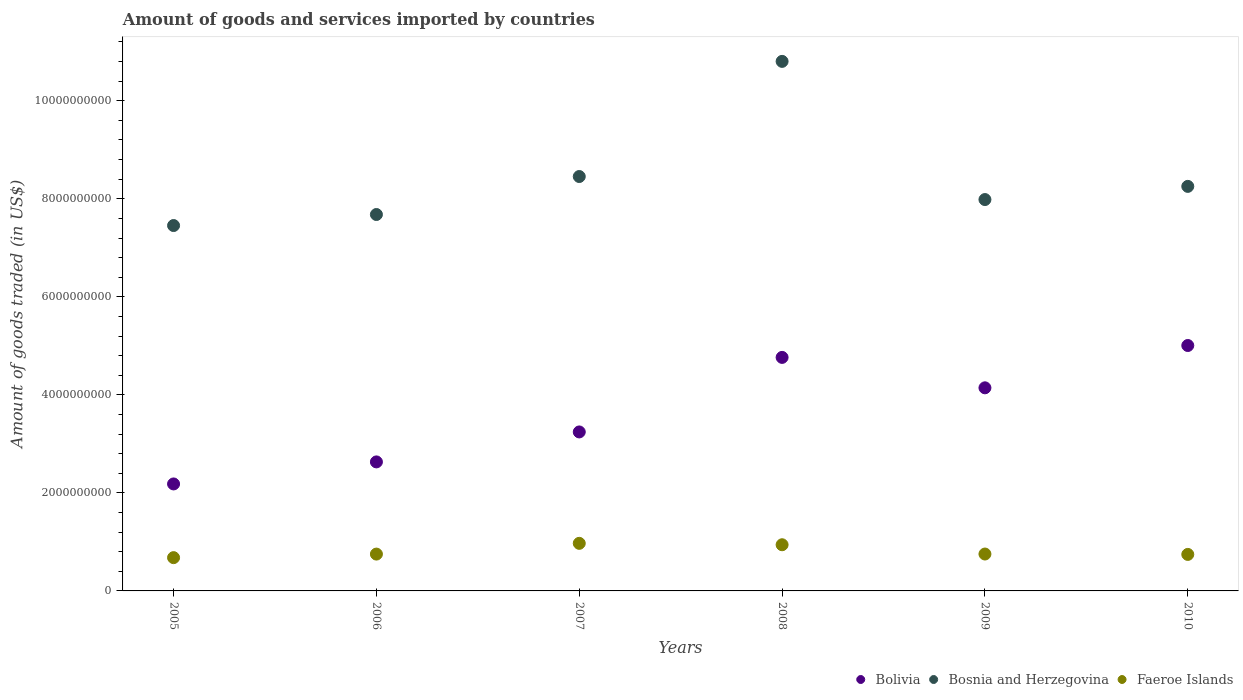What is the total amount of goods and services imported in Faeroe Islands in 2007?
Your answer should be compact. 9.71e+08. Across all years, what is the maximum total amount of goods and services imported in Faeroe Islands?
Make the answer very short. 9.71e+08. Across all years, what is the minimum total amount of goods and services imported in Bosnia and Herzegovina?
Give a very brief answer. 7.45e+09. In which year was the total amount of goods and services imported in Bosnia and Herzegovina maximum?
Provide a succinct answer. 2008. In which year was the total amount of goods and services imported in Faeroe Islands minimum?
Offer a terse response. 2005. What is the total total amount of goods and services imported in Faeroe Islands in the graph?
Your response must be concise. 4.84e+09. What is the difference between the total amount of goods and services imported in Bosnia and Herzegovina in 2006 and that in 2008?
Provide a short and direct response. -3.12e+09. What is the difference between the total amount of goods and services imported in Faeroe Islands in 2006 and the total amount of goods and services imported in Bosnia and Herzegovina in 2009?
Offer a very short reply. -7.23e+09. What is the average total amount of goods and services imported in Bolivia per year?
Offer a very short reply. 3.66e+09. In the year 2007, what is the difference between the total amount of goods and services imported in Faeroe Islands and total amount of goods and services imported in Bolivia?
Keep it short and to the point. -2.27e+09. What is the ratio of the total amount of goods and services imported in Bosnia and Herzegovina in 2008 to that in 2010?
Your answer should be compact. 1.31. Is the difference between the total amount of goods and services imported in Faeroe Islands in 2006 and 2007 greater than the difference between the total amount of goods and services imported in Bolivia in 2006 and 2007?
Make the answer very short. Yes. What is the difference between the highest and the second highest total amount of goods and services imported in Bosnia and Herzegovina?
Ensure brevity in your answer.  2.35e+09. What is the difference between the highest and the lowest total amount of goods and services imported in Bolivia?
Provide a succinct answer. 2.82e+09. In how many years, is the total amount of goods and services imported in Bosnia and Herzegovina greater than the average total amount of goods and services imported in Bosnia and Herzegovina taken over all years?
Make the answer very short. 2. Is the sum of the total amount of goods and services imported in Bolivia in 2006 and 2010 greater than the maximum total amount of goods and services imported in Bosnia and Herzegovina across all years?
Offer a very short reply. No. Does the total amount of goods and services imported in Faeroe Islands monotonically increase over the years?
Provide a succinct answer. No. Is the total amount of goods and services imported in Bolivia strictly greater than the total amount of goods and services imported in Faeroe Islands over the years?
Make the answer very short. Yes. Is the total amount of goods and services imported in Bosnia and Herzegovina strictly less than the total amount of goods and services imported in Bolivia over the years?
Your answer should be compact. No. How many dotlines are there?
Provide a short and direct response. 3. How many years are there in the graph?
Make the answer very short. 6. Are the values on the major ticks of Y-axis written in scientific E-notation?
Offer a terse response. No. Does the graph contain any zero values?
Your answer should be compact. No. Does the graph contain grids?
Offer a terse response. No. Where does the legend appear in the graph?
Your answer should be compact. Bottom right. What is the title of the graph?
Your response must be concise. Amount of goods and services imported by countries. What is the label or title of the Y-axis?
Your response must be concise. Amount of goods traded (in US$). What is the Amount of goods traded (in US$) of Bolivia in 2005?
Give a very brief answer. 2.18e+09. What is the Amount of goods traded (in US$) in Bosnia and Herzegovina in 2005?
Offer a terse response. 7.45e+09. What is the Amount of goods traded (in US$) in Faeroe Islands in 2005?
Your answer should be very brief. 6.79e+08. What is the Amount of goods traded (in US$) of Bolivia in 2006?
Provide a short and direct response. 2.63e+09. What is the Amount of goods traded (in US$) in Bosnia and Herzegovina in 2006?
Give a very brief answer. 7.68e+09. What is the Amount of goods traded (in US$) of Faeroe Islands in 2006?
Ensure brevity in your answer.  7.51e+08. What is the Amount of goods traded (in US$) in Bolivia in 2007?
Offer a terse response. 3.24e+09. What is the Amount of goods traded (in US$) of Bosnia and Herzegovina in 2007?
Your answer should be very brief. 8.45e+09. What is the Amount of goods traded (in US$) of Faeroe Islands in 2007?
Ensure brevity in your answer.  9.71e+08. What is the Amount of goods traded (in US$) in Bolivia in 2008?
Your response must be concise. 4.76e+09. What is the Amount of goods traded (in US$) of Bosnia and Herzegovina in 2008?
Provide a short and direct response. 1.08e+1. What is the Amount of goods traded (in US$) in Faeroe Islands in 2008?
Offer a terse response. 9.42e+08. What is the Amount of goods traded (in US$) in Bolivia in 2009?
Keep it short and to the point. 4.14e+09. What is the Amount of goods traded (in US$) of Bosnia and Herzegovina in 2009?
Your response must be concise. 7.98e+09. What is the Amount of goods traded (in US$) in Faeroe Islands in 2009?
Keep it short and to the point. 7.53e+08. What is the Amount of goods traded (in US$) of Bolivia in 2010?
Ensure brevity in your answer.  5.01e+09. What is the Amount of goods traded (in US$) of Bosnia and Herzegovina in 2010?
Ensure brevity in your answer.  8.25e+09. What is the Amount of goods traded (in US$) of Faeroe Islands in 2010?
Keep it short and to the point. 7.45e+08. Across all years, what is the maximum Amount of goods traded (in US$) in Bolivia?
Provide a succinct answer. 5.01e+09. Across all years, what is the maximum Amount of goods traded (in US$) in Bosnia and Herzegovina?
Give a very brief answer. 1.08e+1. Across all years, what is the maximum Amount of goods traded (in US$) of Faeroe Islands?
Offer a terse response. 9.71e+08. Across all years, what is the minimum Amount of goods traded (in US$) of Bolivia?
Ensure brevity in your answer.  2.18e+09. Across all years, what is the minimum Amount of goods traded (in US$) of Bosnia and Herzegovina?
Keep it short and to the point. 7.45e+09. Across all years, what is the minimum Amount of goods traded (in US$) of Faeroe Islands?
Your answer should be very brief. 6.79e+08. What is the total Amount of goods traded (in US$) of Bolivia in the graph?
Give a very brief answer. 2.20e+1. What is the total Amount of goods traded (in US$) in Bosnia and Herzegovina in the graph?
Your answer should be very brief. 5.06e+1. What is the total Amount of goods traded (in US$) of Faeroe Islands in the graph?
Provide a short and direct response. 4.84e+09. What is the difference between the Amount of goods traded (in US$) in Bolivia in 2005 and that in 2006?
Provide a succinct answer. -4.50e+08. What is the difference between the Amount of goods traded (in US$) in Bosnia and Herzegovina in 2005 and that in 2006?
Provide a short and direct response. -2.25e+08. What is the difference between the Amount of goods traded (in US$) in Faeroe Islands in 2005 and that in 2006?
Offer a very short reply. -7.25e+07. What is the difference between the Amount of goods traded (in US$) in Bolivia in 2005 and that in 2007?
Ensure brevity in your answer.  -1.06e+09. What is the difference between the Amount of goods traded (in US$) of Bosnia and Herzegovina in 2005 and that in 2007?
Provide a short and direct response. -1.00e+09. What is the difference between the Amount of goods traded (in US$) in Faeroe Islands in 2005 and that in 2007?
Make the answer very short. -2.92e+08. What is the difference between the Amount of goods traded (in US$) of Bolivia in 2005 and that in 2008?
Provide a short and direct response. -2.58e+09. What is the difference between the Amount of goods traded (in US$) in Bosnia and Herzegovina in 2005 and that in 2008?
Ensure brevity in your answer.  -3.35e+09. What is the difference between the Amount of goods traded (in US$) in Faeroe Islands in 2005 and that in 2008?
Your answer should be very brief. -2.63e+08. What is the difference between the Amount of goods traded (in US$) in Bolivia in 2005 and that in 2009?
Your answer should be very brief. -1.96e+09. What is the difference between the Amount of goods traded (in US$) in Bosnia and Herzegovina in 2005 and that in 2009?
Your response must be concise. -5.30e+08. What is the difference between the Amount of goods traded (in US$) of Faeroe Islands in 2005 and that in 2009?
Your answer should be very brief. -7.37e+07. What is the difference between the Amount of goods traded (in US$) of Bolivia in 2005 and that in 2010?
Your response must be concise. -2.82e+09. What is the difference between the Amount of goods traded (in US$) in Bosnia and Herzegovina in 2005 and that in 2010?
Provide a short and direct response. -7.99e+08. What is the difference between the Amount of goods traded (in US$) of Faeroe Islands in 2005 and that in 2010?
Your answer should be very brief. -6.58e+07. What is the difference between the Amount of goods traded (in US$) of Bolivia in 2006 and that in 2007?
Provide a succinct answer. -6.11e+08. What is the difference between the Amount of goods traded (in US$) of Bosnia and Herzegovina in 2006 and that in 2007?
Make the answer very short. -7.75e+08. What is the difference between the Amount of goods traded (in US$) in Faeroe Islands in 2006 and that in 2007?
Your response must be concise. -2.19e+08. What is the difference between the Amount of goods traded (in US$) of Bolivia in 2006 and that in 2008?
Your response must be concise. -2.13e+09. What is the difference between the Amount of goods traded (in US$) of Bosnia and Herzegovina in 2006 and that in 2008?
Your answer should be compact. -3.12e+09. What is the difference between the Amount of goods traded (in US$) of Faeroe Islands in 2006 and that in 2008?
Provide a succinct answer. -1.91e+08. What is the difference between the Amount of goods traded (in US$) in Bolivia in 2006 and that in 2009?
Your response must be concise. -1.51e+09. What is the difference between the Amount of goods traded (in US$) in Bosnia and Herzegovina in 2006 and that in 2009?
Provide a succinct answer. -3.05e+08. What is the difference between the Amount of goods traded (in US$) in Faeroe Islands in 2006 and that in 2009?
Provide a short and direct response. -1.19e+06. What is the difference between the Amount of goods traded (in US$) in Bolivia in 2006 and that in 2010?
Your answer should be very brief. -2.37e+09. What is the difference between the Amount of goods traded (in US$) in Bosnia and Herzegovina in 2006 and that in 2010?
Provide a short and direct response. -5.74e+08. What is the difference between the Amount of goods traded (in US$) of Faeroe Islands in 2006 and that in 2010?
Provide a short and direct response. 6.74e+06. What is the difference between the Amount of goods traded (in US$) of Bolivia in 2007 and that in 2008?
Provide a succinct answer. -1.52e+09. What is the difference between the Amount of goods traded (in US$) of Bosnia and Herzegovina in 2007 and that in 2008?
Offer a very short reply. -2.35e+09. What is the difference between the Amount of goods traded (in US$) of Faeroe Islands in 2007 and that in 2008?
Give a very brief answer. 2.87e+07. What is the difference between the Amount of goods traded (in US$) of Bolivia in 2007 and that in 2009?
Ensure brevity in your answer.  -9.00e+08. What is the difference between the Amount of goods traded (in US$) of Bosnia and Herzegovina in 2007 and that in 2009?
Your answer should be very brief. 4.70e+08. What is the difference between the Amount of goods traded (in US$) of Faeroe Islands in 2007 and that in 2009?
Offer a very short reply. 2.18e+08. What is the difference between the Amount of goods traded (in US$) of Bolivia in 2007 and that in 2010?
Offer a terse response. -1.76e+09. What is the difference between the Amount of goods traded (in US$) of Bosnia and Herzegovina in 2007 and that in 2010?
Your answer should be very brief. 2.01e+08. What is the difference between the Amount of goods traded (in US$) in Faeroe Islands in 2007 and that in 2010?
Offer a terse response. 2.26e+08. What is the difference between the Amount of goods traded (in US$) of Bolivia in 2008 and that in 2009?
Ensure brevity in your answer.  6.21e+08. What is the difference between the Amount of goods traded (in US$) in Bosnia and Herzegovina in 2008 and that in 2009?
Give a very brief answer. 2.82e+09. What is the difference between the Amount of goods traded (in US$) of Faeroe Islands in 2008 and that in 2009?
Ensure brevity in your answer.  1.89e+08. What is the difference between the Amount of goods traded (in US$) in Bolivia in 2008 and that in 2010?
Your response must be concise. -2.43e+08. What is the difference between the Amount of goods traded (in US$) in Bosnia and Herzegovina in 2008 and that in 2010?
Offer a terse response. 2.55e+09. What is the difference between the Amount of goods traded (in US$) of Faeroe Islands in 2008 and that in 2010?
Your response must be concise. 1.97e+08. What is the difference between the Amount of goods traded (in US$) in Bolivia in 2009 and that in 2010?
Provide a short and direct response. -8.63e+08. What is the difference between the Amount of goods traded (in US$) in Bosnia and Herzegovina in 2009 and that in 2010?
Your answer should be compact. -2.69e+08. What is the difference between the Amount of goods traded (in US$) of Faeroe Islands in 2009 and that in 2010?
Your answer should be very brief. 7.93e+06. What is the difference between the Amount of goods traded (in US$) in Bolivia in 2005 and the Amount of goods traded (in US$) in Bosnia and Herzegovina in 2006?
Ensure brevity in your answer.  -5.50e+09. What is the difference between the Amount of goods traded (in US$) of Bolivia in 2005 and the Amount of goods traded (in US$) of Faeroe Islands in 2006?
Provide a succinct answer. 1.43e+09. What is the difference between the Amount of goods traded (in US$) in Bosnia and Herzegovina in 2005 and the Amount of goods traded (in US$) in Faeroe Islands in 2006?
Keep it short and to the point. 6.70e+09. What is the difference between the Amount of goods traded (in US$) of Bolivia in 2005 and the Amount of goods traded (in US$) of Bosnia and Herzegovina in 2007?
Give a very brief answer. -6.27e+09. What is the difference between the Amount of goods traded (in US$) of Bolivia in 2005 and the Amount of goods traded (in US$) of Faeroe Islands in 2007?
Your answer should be very brief. 1.21e+09. What is the difference between the Amount of goods traded (in US$) of Bosnia and Herzegovina in 2005 and the Amount of goods traded (in US$) of Faeroe Islands in 2007?
Your answer should be very brief. 6.48e+09. What is the difference between the Amount of goods traded (in US$) in Bolivia in 2005 and the Amount of goods traded (in US$) in Bosnia and Herzegovina in 2008?
Your answer should be very brief. -8.62e+09. What is the difference between the Amount of goods traded (in US$) of Bolivia in 2005 and the Amount of goods traded (in US$) of Faeroe Islands in 2008?
Give a very brief answer. 1.24e+09. What is the difference between the Amount of goods traded (in US$) of Bosnia and Herzegovina in 2005 and the Amount of goods traded (in US$) of Faeroe Islands in 2008?
Make the answer very short. 6.51e+09. What is the difference between the Amount of goods traded (in US$) in Bolivia in 2005 and the Amount of goods traded (in US$) in Bosnia and Herzegovina in 2009?
Your response must be concise. -5.80e+09. What is the difference between the Amount of goods traded (in US$) of Bolivia in 2005 and the Amount of goods traded (in US$) of Faeroe Islands in 2009?
Ensure brevity in your answer.  1.43e+09. What is the difference between the Amount of goods traded (in US$) in Bosnia and Herzegovina in 2005 and the Amount of goods traded (in US$) in Faeroe Islands in 2009?
Give a very brief answer. 6.70e+09. What is the difference between the Amount of goods traded (in US$) of Bolivia in 2005 and the Amount of goods traded (in US$) of Bosnia and Herzegovina in 2010?
Your response must be concise. -6.07e+09. What is the difference between the Amount of goods traded (in US$) in Bolivia in 2005 and the Amount of goods traded (in US$) in Faeroe Islands in 2010?
Give a very brief answer. 1.44e+09. What is the difference between the Amount of goods traded (in US$) in Bosnia and Herzegovina in 2005 and the Amount of goods traded (in US$) in Faeroe Islands in 2010?
Offer a terse response. 6.71e+09. What is the difference between the Amount of goods traded (in US$) in Bolivia in 2006 and the Amount of goods traded (in US$) in Bosnia and Herzegovina in 2007?
Provide a succinct answer. -5.82e+09. What is the difference between the Amount of goods traded (in US$) of Bolivia in 2006 and the Amount of goods traded (in US$) of Faeroe Islands in 2007?
Keep it short and to the point. 1.66e+09. What is the difference between the Amount of goods traded (in US$) of Bosnia and Herzegovina in 2006 and the Amount of goods traded (in US$) of Faeroe Islands in 2007?
Keep it short and to the point. 6.71e+09. What is the difference between the Amount of goods traded (in US$) in Bolivia in 2006 and the Amount of goods traded (in US$) in Bosnia and Herzegovina in 2008?
Offer a terse response. -8.17e+09. What is the difference between the Amount of goods traded (in US$) of Bolivia in 2006 and the Amount of goods traded (in US$) of Faeroe Islands in 2008?
Offer a very short reply. 1.69e+09. What is the difference between the Amount of goods traded (in US$) of Bosnia and Herzegovina in 2006 and the Amount of goods traded (in US$) of Faeroe Islands in 2008?
Keep it short and to the point. 6.74e+09. What is the difference between the Amount of goods traded (in US$) in Bolivia in 2006 and the Amount of goods traded (in US$) in Bosnia and Herzegovina in 2009?
Keep it short and to the point. -5.35e+09. What is the difference between the Amount of goods traded (in US$) in Bolivia in 2006 and the Amount of goods traded (in US$) in Faeroe Islands in 2009?
Provide a short and direct response. 1.88e+09. What is the difference between the Amount of goods traded (in US$) of Bosnia and Herzegovina in 2006 and the Amount of goods traded (in US$) of Faeroe Islands in 2009?
Offer a terse response. 6.93e+09. What is the difference between the Amount of goods traded (in US$) of Bolivia in 2006 and the Amount of goods traded (in US$) of Bosnia and Herzegovina in 2010?
Make the answer very short. -5.62e+09. What is the difference between the Amount of goods traded (in US$) in Bolivia in 2006 and the Amount of goods traded (in US$) in Faeroe Islands in 2010?
Your answer should be very brief. 1.89e+09. What is the difference between the Amount of goods traded (in US$) of Bosnia and Herzegovina in 2006 and the Amount of goods traded (in US$) of Faeroe Islands in 2010?
Offer a very short reply. 6.93e+09. What is the difference between the Amount of goods traded (in US$) of Bolivia in 2007 and the Amount of goods traded (in US$) of Bosnia and Herzegovina in 2008?
Ensure brevity in your answer.  -7.56e+09. What is the difference between the Amount of goods traded (in US$) in Bolivia in 2007 and the Amount of goods traded (in US$) in Faeroe Islands in 2008?
Make the answer very short. 2.30e+09. What is the difference between the Amount of goods traded (in US$) of Bosnia and Herzegovina in 2007 and the Amount of goods traded (in US$) of Faeroe Islands in 2008?
Offer a very short reply. 7.51e+09. What is the difference between the Amount of goods traded (in US$) in Bolivia in 2007 and the Amount of goods traded (in US$) in Bosnia and Herzegovina in 2009?
Make the answer very short. -4.74e+09. What is the difference between the Amount of goods traded (in US$) in Bolivia in 2007 and the Amount of goods traded (in US$) in Faeroe Islands in 2009?
Provide a short and direct response. 2.49e+09. What is the difference between the Amount of goods traded (in US$) of Bosnia and Herzegovina in 2007 and the Amount of goods traded (in US$) of Faeroe Islands in 2009?
Provide a short and direct response. 7.70e+09. What is the difference between the Amount of goods traded (in US$) in Bolivia in 2007 and the Amount of goods traded (in US$) in Bosnia and Herzegovina in 2010?
Offer a very short reply. -5.01e+09. What is the difference between the Amount of goods traded (in US$) in Bolivia in 2007 and the Amount of goods traded (in US$) in Faeroe Islands in 2010?
Offer a very short reply. 2.50e+09. What is the difference between the Amount of goods traded (in US$) of Bosnia and Herzegovina in 2007 and the Amount of goods traded (in US$) of Faeroe Islands in 2010?
Your answer should be very brief. 7.71e+09. What is the difference between the Amount of goods traded (in US$) in Bolivia in 2008 and the Amount of goods traded (in US$) in Bosnia and Herzegovina in 2009?
Provide a succinct answer. -3.22e+09. What is the difference between the Amount of goods traded (in US$) in Bolivia in 2008 and the Amount of goods traded (in US$) in Faeroe Islands in 2009?
Your response must be concise. 4.01e+09. What is the difference between the Amount of goods traded (in US$) in Bosnia and Herzegovina in 2008 and the Amount of goods traded (in US$) in Faeroe Islands in 2009?
Your answer should be very brief. 1.01e+1. What is the difference between the Amount of goods traded (in US$) of Bolivia in 2008 and the Amount of goods traded (in US$) of Bosnia and Herzegovina in 2010?
Give a very brief answer. -3.49e+09. What is the difference between the Amount of goods traded (in US$) in Bolivia in 2008 and the Amount of goods traded (in US$) in Faeroe Islands in 2010?
Keep it short and to the point. 4.02e+09. What is the difference between the Amount of goods traded (in US$) of Bosnia and Herzegovina in 2008 and the Amount of goods traded (in US$) of Faeroe Islands in 2010?
Your response must be concise. 1.01e+1. What is the difference between the Amount of goods traded (in US$) in Bolivia in 2009 and the Amount of goods traded (in US$) in Bosnia and Herzegovina in 2010?
Give a very brief answer. -4.11e+09. What is the difference between the Amount of goods traded (in US$) in Bolivia in 2009 and the Amount of goods traded (in US$) in Faeroe Islands in 2010?
Keep it short and to the point. 3.40e+09. What is the difference between the Amount of goods traded (in US$) in Bosnia and Herzegovina in 2009 and the Amount of goods traded (in US$) in Faeroe Islands in 2010?
Your response must be concise. 7.24e+09. What is the average Amount of goods traded (in US$) of Bolivia per year?
Give a very brief answer. 3.66e+09. What is the average Amount of goods traded (in US$) in Bosnia and Herzegovina per year?
Your response must be concise. 8.44e+09. What is the average Amount of goods traded (in US$) of Faeroe Islands per year?
Provide a succinct answer. 8.07e+08. In the year 2005, what is the difference between the Amount of goods traded (in US$) in Bolivia and Amount of goods traded (in US$) in Bosnia and Herzegovina?
Your answer should be very brief. -5.27e+09. In the year 2005, what is the difference between the Amount of goods traded (in US$) of Bolivia and Amount of goods traded (in US$) of Faeroe Islands?
Make the answer very short. 1.50e+09. In the year 2005, what is the difference between the Amount of goods traded (in US$) in Bosnia and Herzegovina and Amount of goods traded (in US$) in Faeroe Islands?
Provide a succinct answer. 6.78e+09. In the year 2006, what is the difference between the Amount of goods traded (in US$) in Bolivia and Amount of goods traded (in US$) in Bosnia and Herzegovina?
Keep it short and to the point. -5.05e+09. In the year 2006, what is the difference between the Amount of goods traded (in US$) in Bolivia and Amount of goods traded (in US$) in Faeroe Islands?
Give a very brief answer. 1.88e+09. In the year 2006, what is the difference between the Amount of goods traded (in US$) in Bosnia and Herzegovina and Amount of goods traded (in US$) in Faeroe Islands?
Give a very brief answer. 6.93e+09. In the year 2007, what is the difference between the Amount of goods traded (in US$) in Bolivia and Amount of goods traded (in US$) in Bosnia and Herzegovina?
Offer a terse response. -5.21e+09. In the year 2007, what is the difference between the Amount of goods traded (in US$) of Bolivia and Amount of goods traded (in US$) of Faeroe Islands?
Give a very brief answer. 2.27e+09. In the year 2007, what is the difference between the Amount of goods traded (in US$) in Bosnia and Herzegovina and Amount of goods traded (in US$) in Faeroe Islands?
Your response must be concise. 7.48e+09. In the year 2008, what is the difference between the Amount of goods traded (in US$) in Bolivia and Amount of goods traded (in US$) in Bosnia and Herzegovina?
Your answer should be compact. -6.04e+09. In the year 2008, what is the difference between the Amount of goods traded (in US$) of Bolivia and Amount of goods traded (in US$) of Faeroe Islands?
Give a very brief answer. 3.82e+09. In the year 2008, what is the difference between the Amount of goods traded (in US$) of Bosnia and Herzegovina and Amount of goods traded (in US$) of Faeroe Islands?
Offer a terse response. 9.86e+09. In the year 2009, what is the difference between the Amount of goods traded (in US$) in Bolivia and Amount of goods traded (in US$) in Bosnia and Herzegovina?
Provide a succinct answer. -3.84e+09. In the year 2009, what is the difference between the Amount of goods traded (in US$) in Bolivia and Amount of goods traded (in US$) in Faeroe Islands?
Your answer should be very brief. 3.39e+09. In the year 2009, what is the difference between the Amount of goods traded (in US$) in Bosnia and Herzegovina and Amount of goods traded (in US$) in Faeroe Islands?
Ensure brevity in your answer.  7.23e+09. In the year 2010, what is the difference between the Amount of goods traded (in US$) of Bolivia and Amount of goods traded (in US$) of Bosnia and Herzegovina?
Offer a very short reply. -3.25e+09. In the year 2010, what is the difference between the Amount of goods traded (in US$) in Bolivia and Amount of goods traded (in US$) in Faeroe Islands?
Your answer should be very brief. 4.26e+09. In the year 2010, what is the difference between the Amount of goods traded (in US$) in Bosnia and Herzegovina and Amount of goods traded (in US$) in Faeroe Islands?
Provide a short and direct response. 7.51e+09. What is the ratio of the Amount of goods traded (in US$) of Bolivia in 2005 to that in 2006?
Provide a short and direct response. 0.83. What is the ratio of the Amount of goods traded (in US$) in Bosnia and Herzegovina in 2005 to that in 2006?
Keep it short and to the point. 0.97. What is the ratio of the Amount of goods traded (in US$) of Faeroe Islands in 2005 to that in 2006?
Your answer should be compact. 0.9. What is the ratio of the Amount of goods traded (in US$) of Bolivia in 2005 to that in 2007?
Your response must be concise. 0.67. What is the ratio of the Amount of goods traded (in US$) of Bosnia and Herzegovina in 2005 to that in 2007?
Offer a very short reply. 0.88. What is the ratio of the Amount of goods traded (in US$) in Faeroe Islands in 2005 to that in 2007?
Give a very brief answer. 0.7. What is the ratio of the Amount of goods traded (in US$) in Bolivia in 2005 to that in 2008?
Provide a succinct answer. 0.46. What is the ratio of the Amount of goods traded (in US$) in Bosnia and Herzegovina in 2005 to that in 2008?
Your answer should be compact. 0.69. What is the ratio of the Amount of goods traded (in US$) in Faeroe Islands in 2005 to that in 2008?
Give a very brief answer. 0.72. What is the ratio of the Amount of goods traded (in US$) of Bolivia in 2005 to that in 2009?
Your answer should be very brief. 0.53. What is the ratio of the Amount of goods traded (in US$) of Bosnia and Herzegovina in 2005 to that in 2009?
Make the answer very short. 0.93. What is the ratio of the Amount of goods traded (in US$) in Faeroe Islands in 2005 to that in 2009?
Offer a terse response. 0.9. What is the ratio of the Amount of goods traded (in US$) in Bolivia in 2005 to that in 2010?
Your response must be concise. 0.44. What is the ratio of the Amount of goods traded (in US$) in Bosnia and Herzegovina in 2005 to that in 2010?
Ensure brevity in your answer.  0.9. What is the ratio of the Amount of goods traded (in US$) in Faeroe Islands in 2005 to that in 2010?
Give a very brief answer. 0.91. What is the ratio of the Amount of goods traded (in US$) of Bolivia in 2006 to that in 2007?
Your answer should be compact. 0.81. What is the ratio of the Amount of goods traded (in US$) of Bosnia and Herzegovina in 2006 to that in 2007?
Give a very brief answer. 0.91. What is the ratio of the Amount of goods traded (in US$) of Faeroe Islands in 2006 to that in 2007?
Your answer should be very brief. 0.77. What is the ratio of the Amount of goods traded (in US$) of Bolivia in 2006 to that in 2008?
Your answer should be very brief. 0.55. What is the ratio of the Amount of goods traded (in US$) in Bosnia and Herzegovina in 2006 to that in 2008?
Your answer should be very brief. 0.71. What is the ratio of the Amount of goods traded (in US$) in Faeroe Islands in 2006 to that in 2008?
Give a very brief answer. 0.8. What is the ratio of the Amount of goods traded (in US$) of Bolivia in 2006 to that in 2009?
Ensure brevity in your answer.  0.64. What is the ratio of the Amount of goods traded (in US$) in Bosnia and Herzegovina in 2006 to that in 2009?
Keep it short and to the point. 0.96. What is the ratio of the Amount of goods traded (in US$) of Bolivia in 2006 to that in 2010?
Keep it short and to the point. 0.53. What is the ratio of the Amount of goods traded (in US$) in Bosnia and Herzegovina in 2006 to that in 2010?
Make the answer very short. 0.93. What is the ratio of the Amount of goods traded (in US$) in Faeroe Islands in 2006 to that in 2010?
Ensure brevity in your answer.  1.01. What is the ratio of the Amount of goods traded (in US$) of Bolivia in 2007 to that in 2008?
Provide a short and direct response. 0.68. What is the ratio of the Amount of goods traded (in US$) of Bosnia and Herzegovina in 2007 to that in 2008?
Your answer should be compact. 0.78. What is the ratio of the Amount of goods traded (in US$) of Faeroe Islands in 2007 to that in 2008?
Make the answer very short. 1.03. What is the ratio of the Amount of goods traded (in US$) of Bolivia in 2007 to that in 2009?
Make the answer very short. 0.78. What is the ratio of the Amount of goods traded (in US$) of Bosnia and Herzegovina in 2007 to that in 2009?
Make the answer very short. 1.06. What is the ratio of the Amount of goods traded (in US$) in Faeroe Islands in 2007 to that in 2009?
Provide a short and direct response. 1.29. What is the ratio of the Amount of goods traded (in US$) of Bolivia in 2007 to that in 2010?
Make the answer very short. 0.65. What is the ratio of the Amount of goods traded (in US$) of Bosnia and Herzegovina in 2007 to that in 2010?
Keep it short and to the point. 1.02. What is the ratio of the Amount of goods traded (in US$) of Faeroe Islands in 2007 to that in 2010?
Make the answer very short. 1.3. What is the ratio of the Amount of goods traded (in US$) of Bolivia in 2008 to that in 2009?
Make the answer very short. 1.15. What is the ratio of the Amount of goods traded (in US$) of Bosnia and Herzegovina in 2008 to that in 2009?
Give a very brief answer. 1.35. What is the ratio of the Amount of goods traded (in US$) of Faeroe Islands in 2008 to that in 2009?
Your response must be concise. 1.25. What is the ratio of the Amount of goods traded (in US$) of Bolivia in 2008 to that in 2010?
Your answer should be compact. 0.95. What is the ratio of the Amount of goods traded (in US$) of Bosnia and Herzegovina in 2008 to that in 2010?
Provide a short and direct response. 1.31. What is the ratio of the Amount of goods traded (in US$) in Faeroe Islands in 2008 to that in 2010?
Your answer should be compact. 1.26. What is the ratio of the Amount of goods traded (in US$) of Bolivia in 2009 to that in 2010?
Your response must be concise. 0.83. What is the ratio of the Amount of goods traded (in US$) in Bosnia and Herzegovina in 2009 to that in 2010?
Offer a very short reply. 0.97. What is the ratio of the Amount of goods traded (in US$) in Faeroe Islands in 2009 to that in 2010?
Provide a short and direct response. 1.01. What is the difference between the highest and the second highest Amount of goods traded (in US$) in Bolivia?
Give a very brief answer. 2.43e+08. What is the difference between the highest and the second highest Amount of goods traded (in US$) of Bosnia and Herzegovina?
Provide a succinct answer. 2.35e+09. What is the difference between the highest and the second highest Amount of goods traded (in US$) in Faeroe Islands?
Make the answer very short. 2.87e+07. What is the difference between the highest and the lowest Amount of goods traded (in US$) in Bolivia?
Give a very brief answer. 2.82e+09. What is the difference between the highest and the lowest Amount of goods traded (in US$) of Bosnia and Herzegovina?
Provide a short and direct response. 3.35e+09. What is the difference between the highest and the lowest Amount of goods traded (in US$) in Faeroe Islands?
Offer a very short reply. 2.92e+08. 